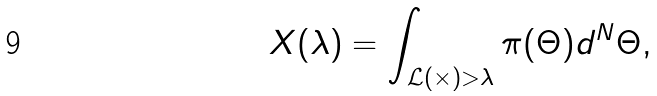<formula> <loc_0><loc_0><loc_500><loc_500>X ( \lambda ) = \int _ { \mathcal { L \left ( \Theta \right ) > \lambda } } \pi ( \Theta ) d ^ { N } \Theta ,</formula> 